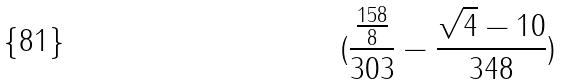<formula> <loc_0><loc_0><loc_500><loc_500>( \frac { \frac { 1 5 8 } { 8 } } { 3 0 3 } - \frac { \sqrt { 4 } - 1 0 } { 3 4 8 } )</formula> 